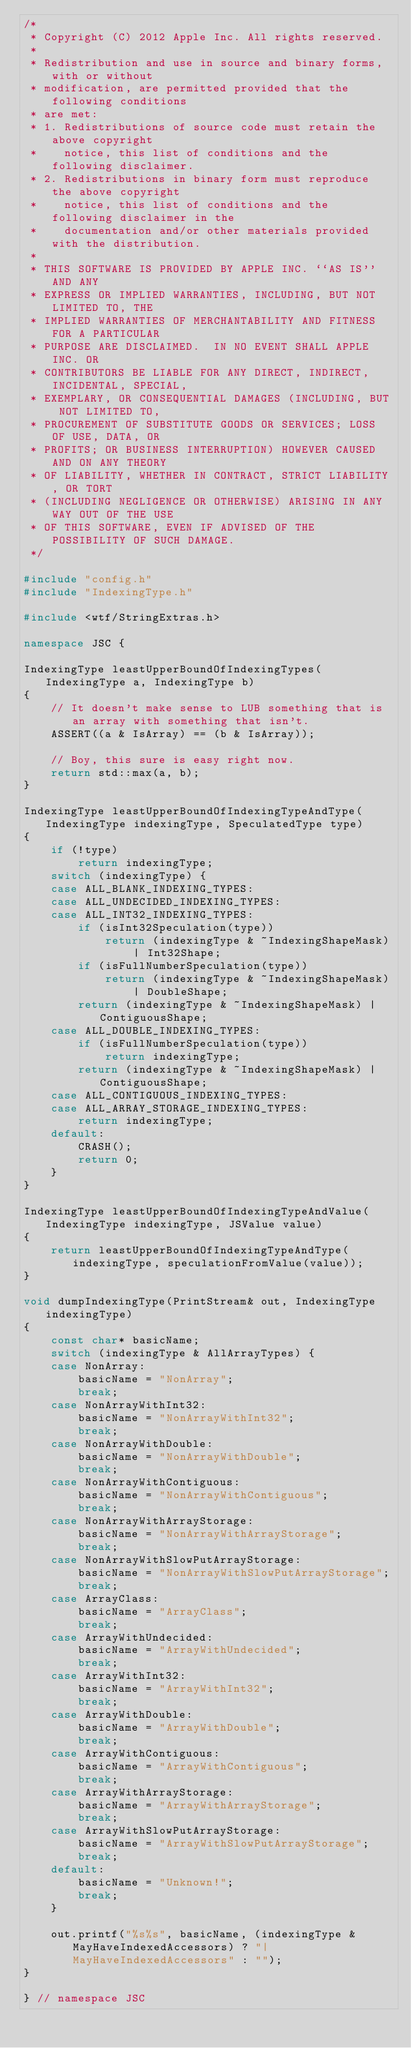<code> <loc_0><loc_0><loc_500><loc_500><_C++_>/*
 * Copyright (C) 2012 Apple Inc. All rights reserved.
 *
 * Redistribution and use in source and binary forms, with or without
 * modification, are permitted provided that the following conditions
 * are met:
 * 1. Redistributions of source code must retain the above copyright
 *    notice, this list of conditions and the following disclaimer.
 * 2. Redistributions in binary form must reproduce the above copyright
 *    notice, this list of conditions and the following disclaimer in the
 *    documentation and/or other materials provided with the distribution.
 *
 * THIS SOFTWARE IS PROVIDED BY APPLE INC. ``AS IS'' AND ANY
 * EXPRESS OR IMPLIED WARRANTIES, INCLUDING, BUT NOT LIMITED TO, THE
 * IMPLIED WARRANTIES OF MERCHANTABILITY AND FITNESS FOR A PARTICULAR
 * PURPOSE ARE DISCLAIMED.  IN NO EVENT SHALL APPLE INC. OR
 * CONTRIBUTORS BE LIABLE FOR ANY DIRECT, INDIRECT, INCIDENTAL, SPECIAL,
 * EXEMPLARY, OR CONSEQUENTIAL DAMAGES (INCLUDING, BUT NOT LIMITED TO,
 * PROCUREMENT OF SUBSTITUTE GOODS OR SERVICES; LOSS OF USE, DATA, OR
 * PROFITS; OR BUSINESS INTERRUPTION) HOWEVER CAUSED AND ON ANY THEORY
 * OF LIABILITY, WHETHER IN CONTRACT, STRICT LIABILITY, OR TORT
 * (INCLUDING NEGLIGENCE OR OTHERWISE) ARISING IN ANY WAY OUT OF THE USE
 * OF THIS SOFTWARE, EVEN IF ADVISED OF THE POSSIBILITY OF SUCH DAMAGE. 
 */

#include "config.h"
#include "IndexingType.h"

#include <wtf/StringExtras.h>

namespace JSC {

IndexingType leastUpperBoundOfIndexingTypes(IndexingType a, IndexingType b)
{
    // It doesn't make sense to LUB something that is an array with something that isn't.
    ASSERT((a & IsArray) == (b & IsArray));

    // Boy, this sure is easy right now.
    return std::max(a, b);
}

IndexingType leastUpperBoundOfIndexingTypeAndType(IndexingType indexingType, SpeculatedType type)
{
    if (!type)
        return indexingType;
    switch (indexingType) {
    case ALL_BLANK_INDEXING_TYPES:
    case ALL_UNDECIDED_INDEXING_TYPES:
    case ALL_INT32_INDEXING_TYPES:
        if (isInt32Speculation(type))
            return (indexingType & ~IndexingShapeMask) | Int32Shape;
        if (isFullNumberSpeculation(type))
            return (indexingType & ~IndexingShapeMask) | DoubleShape;
        return (indexingType & ~IndexingShapeMask) | ContiguousShape;
    case ALL_DOUBLE_INDEXING_TYPES:
        if (isFullNumberSpeculation(type))
            return indexingType;
        return (indexingType & ~IndexingShapeMask) | ContiguousShape;
    case ALL_CONTIGUOUS_INDEXING_TYPES:
    case ALL_ARRAY_STORAGE_INDEXING_TYPES:
        return indexingType;
    default:
        CRASH();
        return 0;
    }
}

IndexingType leastUpperBoundOfIndexingTypeAndValue(IndexingType indexingType, JSValue value)
{
    return leastUpperBoundOfIndexingTypeAndType(indexingType, speculationFromValue(value));
}

void dumpIndexingType(PrintStream& out, IndexingType indexingType)
{
    const char* basicName;
    switch (indexingType & AllArrayTypes) {
    case NonArray:
        basicName = "NonArray";
        break;
    case NonArrayWithInt32:
        basicName = "NonArrayWithInt32";
        break;
    case NonArrayWithDouble:
        basicName = "NonArrayWithDouble";
        break;
    case NonArrayWithContiguous:
        basicName = "NonArrayWithContiguous";
        break;
    case NonArrayWithArrayStorage:
        basicName = "NonArrayWithArrayStorage";
        break;
    case NonArrayWithSlowPutArrayStorage:
        basicName = "NonArrayWithSlowPutArrayStorage";
        break;
    case ArrayClass:
        basicName = "ArrayClass";
        break;
    case ArrayWithUndecided:
        basicName = "ArrayWithUndecided";
        break;
    case ArrayWithInt32:
        basicName = "ArrayWithInt32";
        break;
    case ArrayWithDouble:
        basicName = "ArrayWithDouble";
        break;
    case ArrayWithContiguous:
        basicName = "ArrayWithContiguous";
        break;
    case ArrayWithArrayStorage:
        basicName = "ArrayWithArrayStorage";
        break;
    case ArrayWithSlowPutArrayStorage:
        basicName = "ArrayWithSlowPutArrayStorage";
        break;
    default:
        basicName = "Unknown!";
        break;
    }
    
    out.printf("%s%s", basicName, (indexingType & MayHaveIndexedAccessors) ? "|MayHaveIndexedAccessors" : "");
}

} // namespace JSC

</code> 